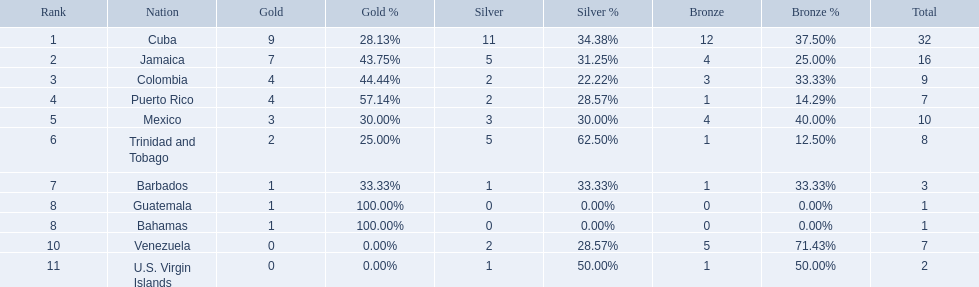Which teams have at exactly 4 gold medals? Colombia, Puerto Rico. Of those teams which has exactly 1 bronze medal? Puerto Rico. 